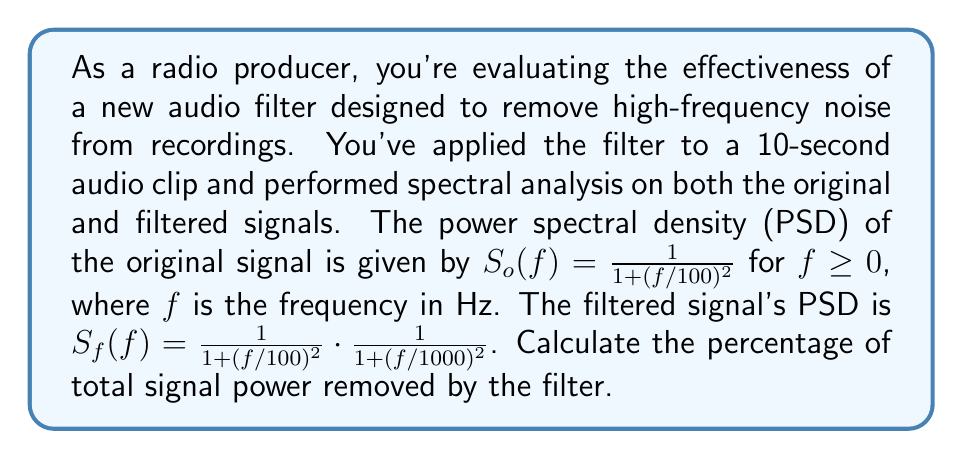Help me with this question. To solve this problem, we need to follow these steps:

1) First, we need to calculate the total power of the original signal. The total power is given by the integral of the PSD over all frequencies:

   $$P_o = \int_0^\infty S_o(f) df = \int_0^\infty \frac{1}{1 + (f/100)^2} df$$

2) This integral can be solved using the substitution $u = f/100$, $du = df/100$:

   $$P_o = 100 \int_0^\infty \frac{1}{1 + u^2} du = 100 \cdot \frac{\pi}{2} = 50\pi$$

3) Next, we calculate the total power of the filtered signal:

   $$P_f = \int_0^\infty S_f(f) df = \int_0^\infty \frac{1}{1 + (f/100)^2} \cdot \frac{1}{1 + (f/1000)^2} df$$

4) This integral is more complex, but it can be solved using partial fraction decomposition:

   $$P_f = 100 \int_0^\infty \frac{1}{(1 + u^2)(1 + (u/10)^2)} du = 100 \cdot \frac{9\pi}{20} = 45\pi$$

5) The power removed by the filter is the difference between these:

   $$P_{\text{removed}} = P_o - P_f = 50\pi - 45\pi = 5\pi$$

6) To express this as a percentage, we divide by the original power and multiply by 100:

   $$\text{Percentage removed} = \frac{P_{\text{removed}}}{P_o} \cdot 100\% = \frac{5\pi}{50\pi} \cdot 100\% = 10\%$$

Therefore, the filter removes 10% of the total signal power.
Answer: 10% 